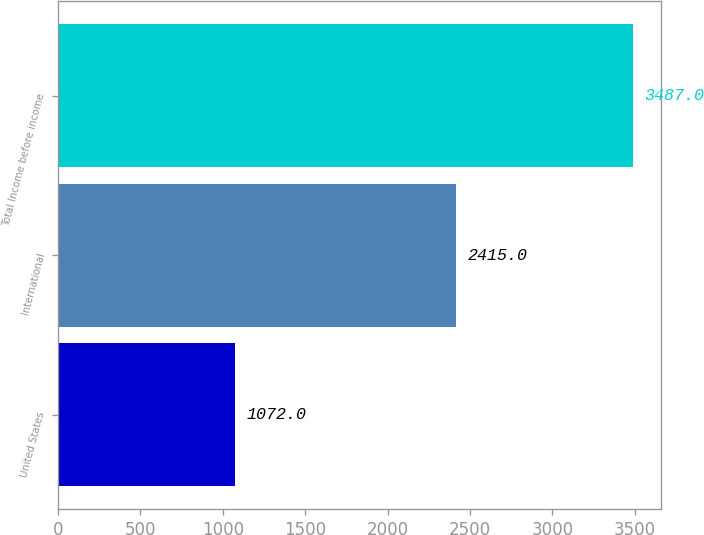Convert chart to OTSL. <chart><loc_0><loc_0><loc_500><loc_500><bar_chart><fcel>United States<fcel>International<fcel>Total Income before income<nl><fcel>1072<fcel>2415<fcel>3487<nl></chart> 